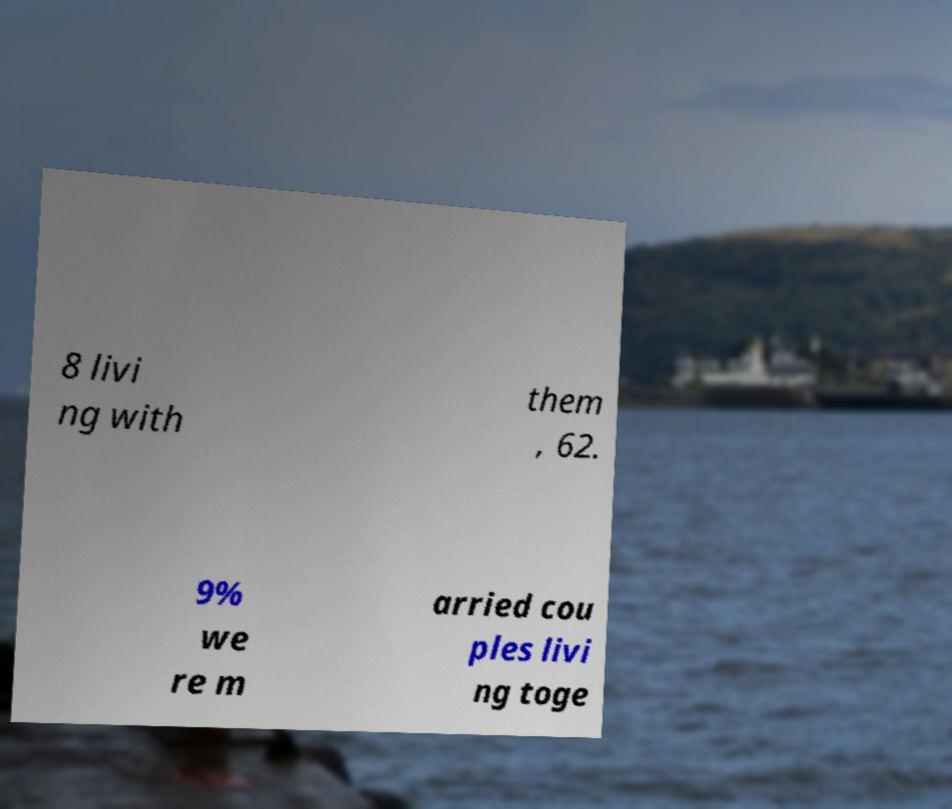For documentation purposes, I need the text within this image transcribed. Could you provide that? 8 livi ng with them , 62. 9% we re m arried cou ples livi ng toge 